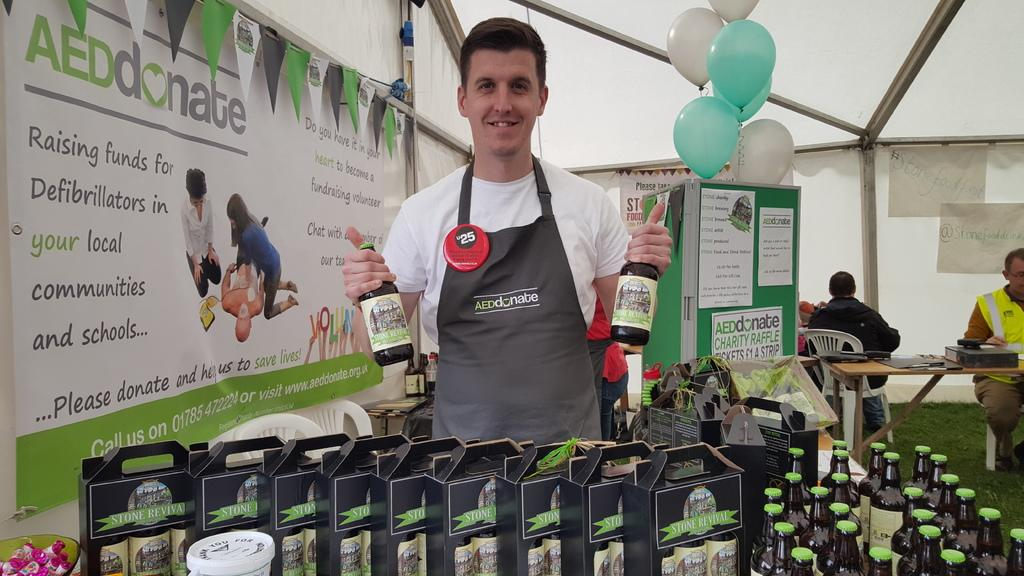What is the man in the image doing? The man is standing in the image and holding two bottles. What can be seen in the background of the image? There are cardboard boxes, bottles on a table, a hoarding, balloons, a tent, and a banner in the background of the image. How many bottles is the man holding? The man is holding two bottles. What might be the purpose of the tent in the background? The tent in the background might be used for shelter or as a part of an event. What type of quill is the man using to write on the plastic seashore in the image? There is no quill or plastic seashore present in the image. 